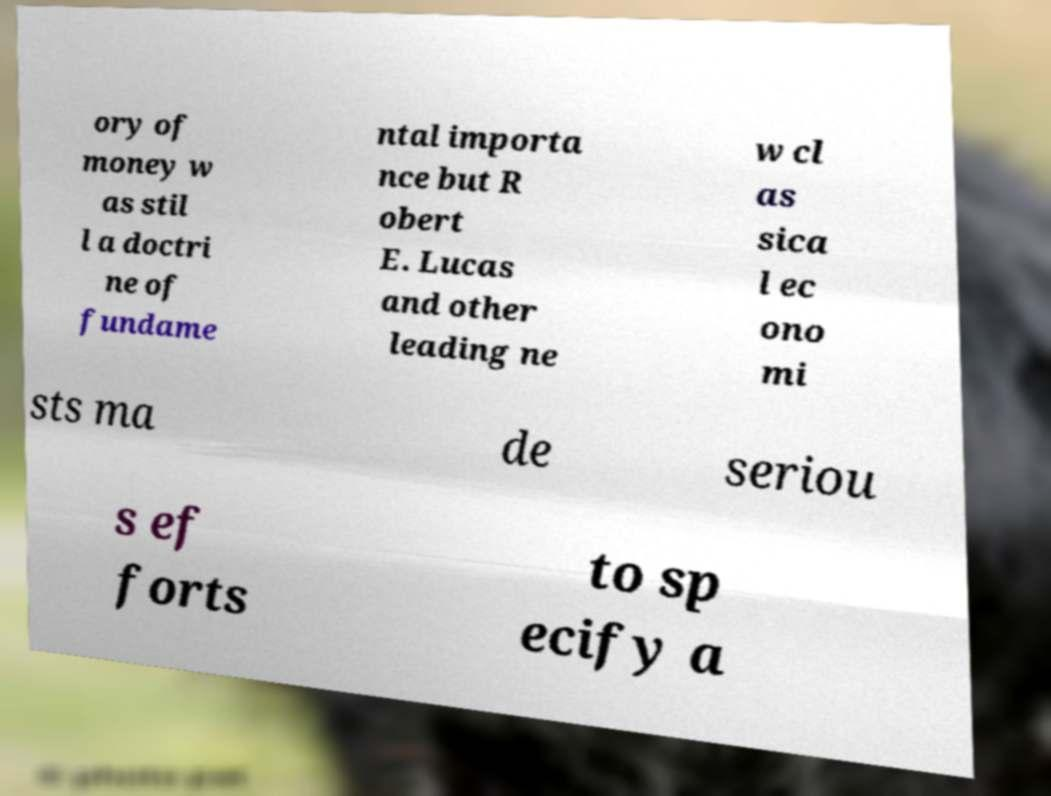There's text embedded in this image that I need extracted. Can you transcribe it verbatim? ory of money w as stil l a doctri ne of fundame ntal importa nce but R obert E. Lucas and other leading ne w cl as sica l ec ono mi sts ma de seriou s ef forts to sp ecify a 